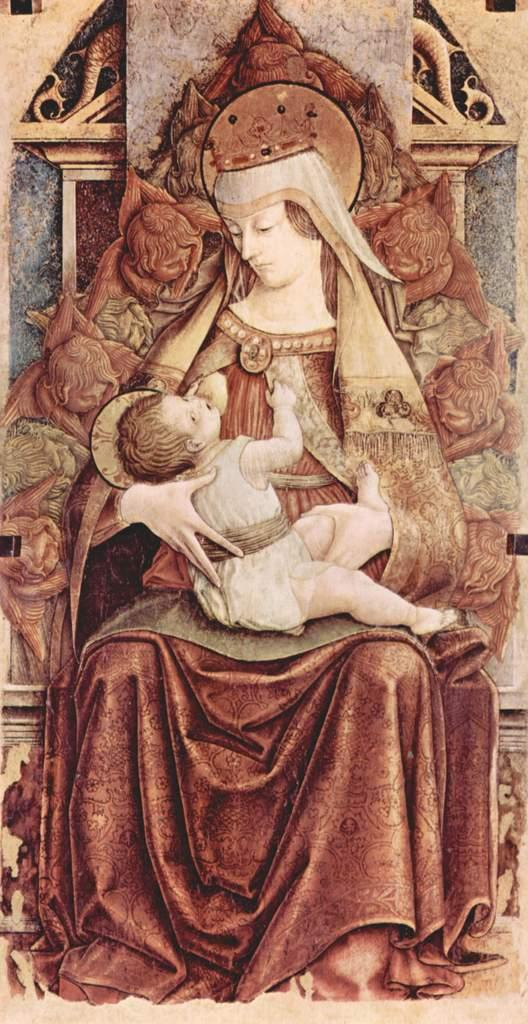What is the main subject of the painting in the image? The painting depicts a woman sitting on a chair. What is the woman doing in the painting? The woman is holding a baby in her hands. What can be seen in the background of the painting? There is a wall with carvings in the background of the painting. What type of worm can be seen crawling on the tent in the image? There is no tent or worm present in the image; it features a painting of a woman holding a baby. What is the reason for the woman holding the baby in the painting? The painting does not provide a reason for the woman holding the baby; it simply depicts the scene. 